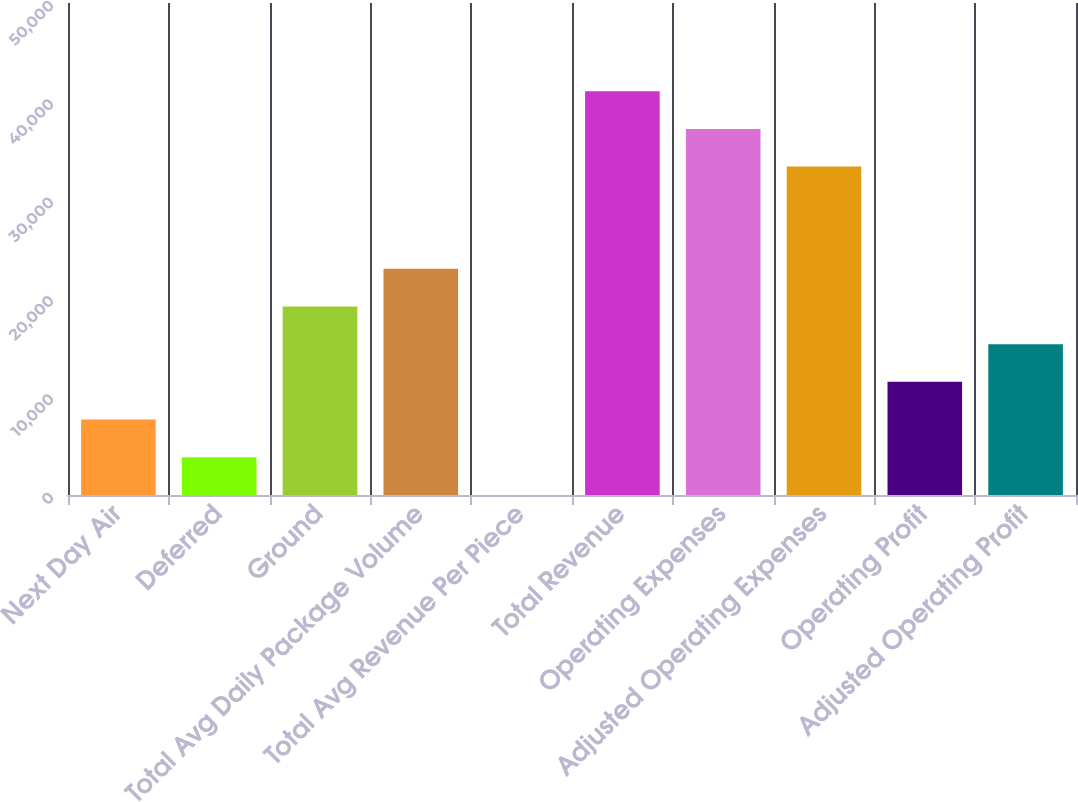<chart> <loc_0><loc_0><loc_500><loc_500><bar_chart><fcel>Next Day Air<fcel>Deferred<fcel>Ground<fcel>Total Avg Daily Package Volume<fcel>Total Avg Revenue Per Piece<fcel>Total Revenue<fcel>Operating Expenses<fcel>Adjusted Operating Expenses<fcel>Operating Profit<fcel>Adjusted Operating Profit<nl><fcel>7667.6<fcel>3838.43<fcel>19155.1<fcel>22984.3<fcel>9.25<fcel>41034.4<fcel>37205.2<fcel>33376<fcel>11496.8<fcel>15326<nl></chart> 